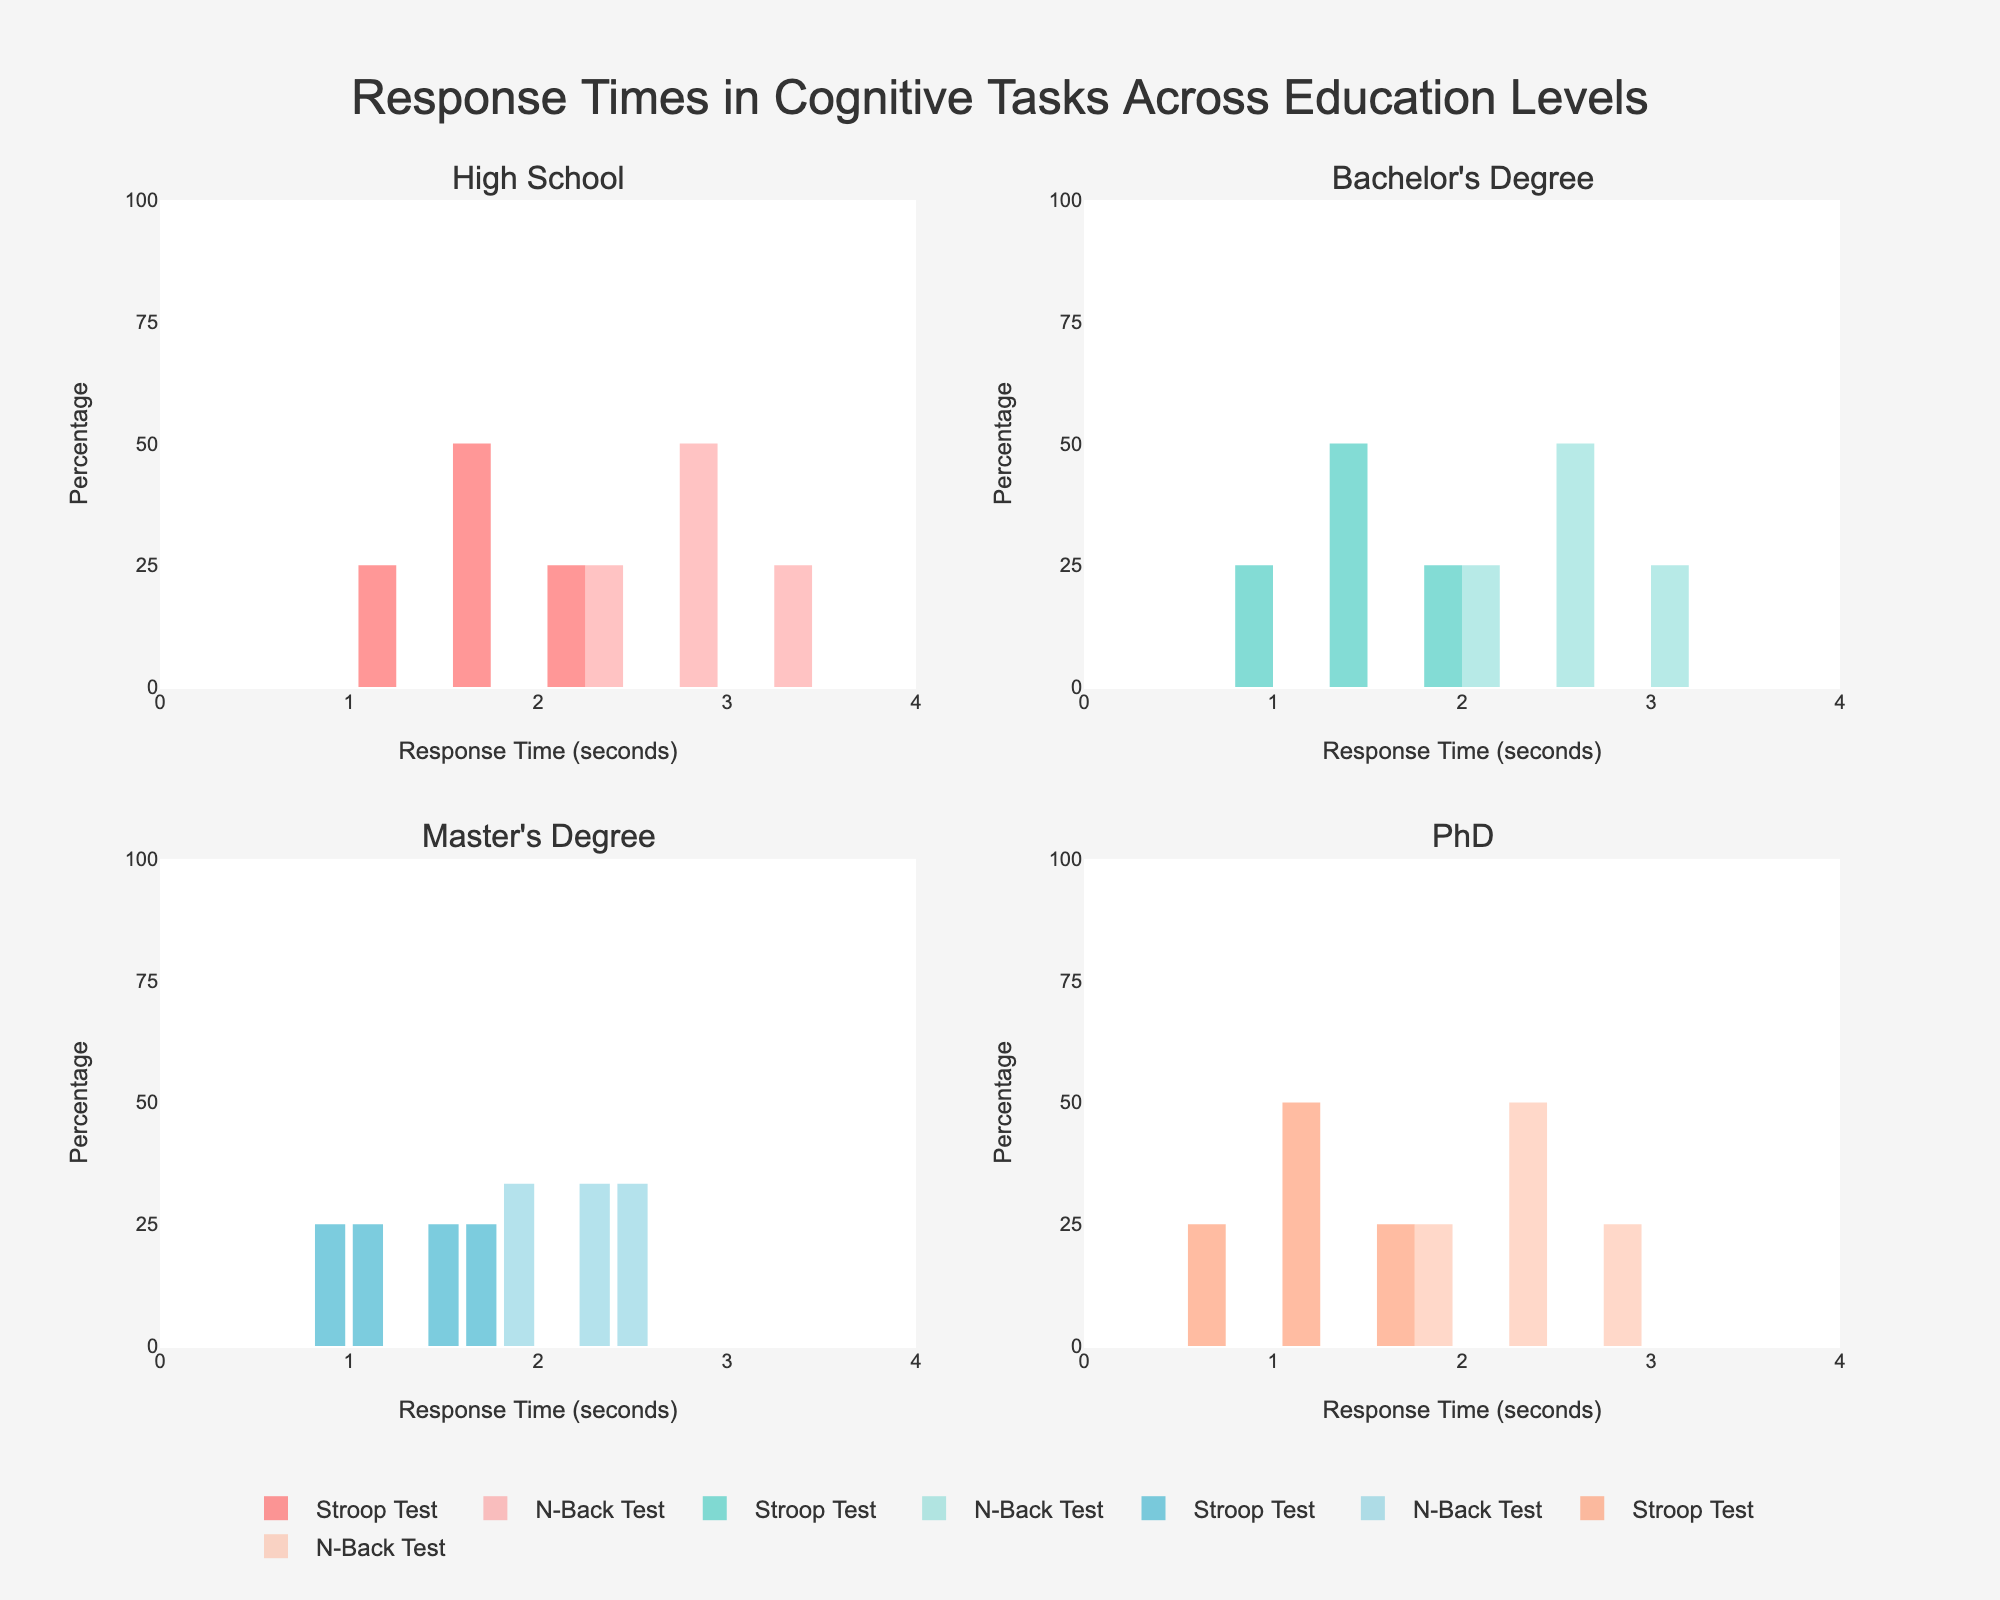What is the title of the figure? The title is prominently located at the top center of the figure, and it reads "Response Times in Cognitive Tasks Across Education Levels." This summarises what the figure is about, which is comparing response times in different cognitive tasks across various educational levels.
Answer: Response Times in Cognitive Tasks Across Education Levels How many subplots are present in the figure? By examining the layout, you can see that there are four distinct subplots, each representing different education levels. These subplots are labeled: 'High School', "Bachelor's Degree", "Master's Degree", and 'PhD'.
Answer: Four Which subplot shows the fastest response times in the Stroop Test? By looking at the x-axis distribution of response times in each subplot, the 'PhD' subplot has response times that start from 0.7 seconds, which is the fastest among all education levels.
Answer: PhD What is the range of response times displayed on the x-axis? The x-axis across all subplots is labeled for a range of 0 to 4 seconds, which can be observed by examining the x-axis limits and tick marks in each subplot.
Answer: 0 to 4 seconds What are the colors used to represent the Stroop Test and N-Back Test? The figure uses different opacities of a color for the two tasks. The Stroop Test is represented by a solid color, while the N-Back Test uses a lighter, more translucent version of the same color. These visually differentiate the tasks in each subplot.
Answer: Solid color for Stroop Test, lighter color for N-Back Test Which education level shows the highest percentage in response times for the Stroop Test in the 1 to 2 second range? In the subplots for each education level, visualize the bars for the Stroop Test within the 1 to 2 second range. The 'High School' subplot has the highest percentage bars in this range compared to other subplots.
Answer: High School For Bachelor's Degree, which task has a more spread-out distribution of response times? Looking at the subplot for “Bachelor's Degree," compare the Histograms for the Stroop Test and the N-Back Test. The N-Back Test shows a more spread-out distribution with response times from 2.1 to 3.0 seconds, whereas the Stroop Test is more concentrated.
Answer: N-Back Test What is the maximum y-axis percentage value across all subplots? Observing the y-axis across all subplots, the maximum percentage value that appears on any y-axis is 100%, which can be seen by looking at the range of percentage ticks.
Answer: 100% Do any education levels show overlapping response times for both tasks? Examining each subplot, the response times for the Stroop Test and N-Back Test overlap in the Bachelor's Degree subplot (1.0 to 1.9 seconds for Stroop Test and 2.1 to 3.0 seconds for N-Back Test), and so on for other education levels, signifying overlapping values in some segments.
Answer: Yes Which task had a generally faster response time for individuals with a Master's Degree? In the subplot labeled "Master's Degree," the distribution of the Stroop Test responses is generally faster (ranging from 0.8 to 1.7 seconds) compared to the N-Back Test (ranging from 1.9 to 2.8 seconds).
Answer: Stroop Test 